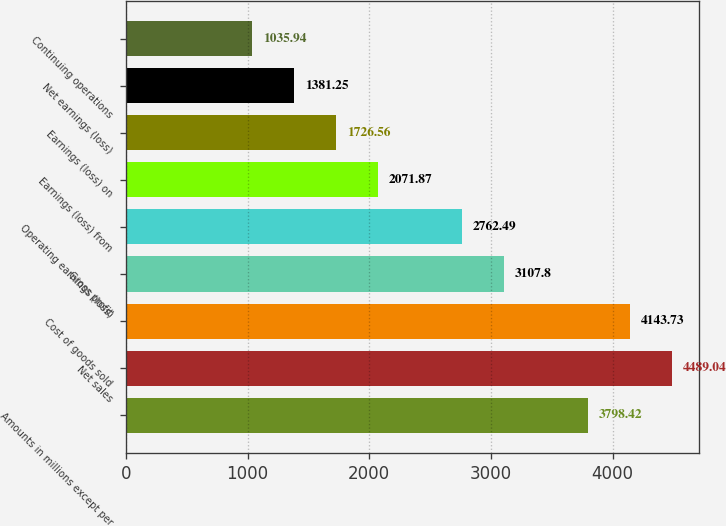Convert chart to OTSL. <chart><loc_0><loc_0><loc_500><loc_500><bar_chart><fcel>Amounts in millions except per<fcel>Net sales<fcel>Cost of goods sold<fcel>Gross profit<fcel>Operating earnings (loss)<fcel>Earnings (loss) from<fcel>Earnings (loss) on<fcel>Net earnings (loss)<fcel>Continuing operations<nl><fcel>3798.42<fcel>4489.04<fcel>4143.73<fcel>3107.8<fcel>2762.49<fcel>2071.87<fcel>1726.56<fcel>1381.25<fcel>1035.94<nl></chart> 